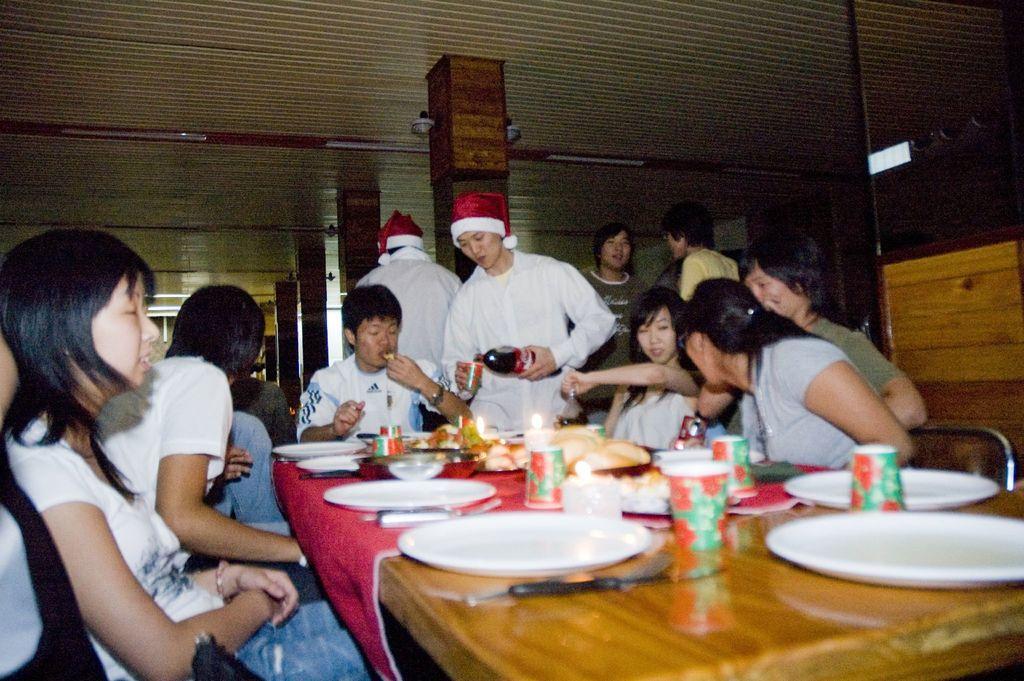Can you describe this image briefly? The image is taken in the restaurant. In the center of the image there is a table. There are many people sitting around the table. There are plates, spoons, forks, glasses and some food placed on the table we can see lights which are attached to the top. 